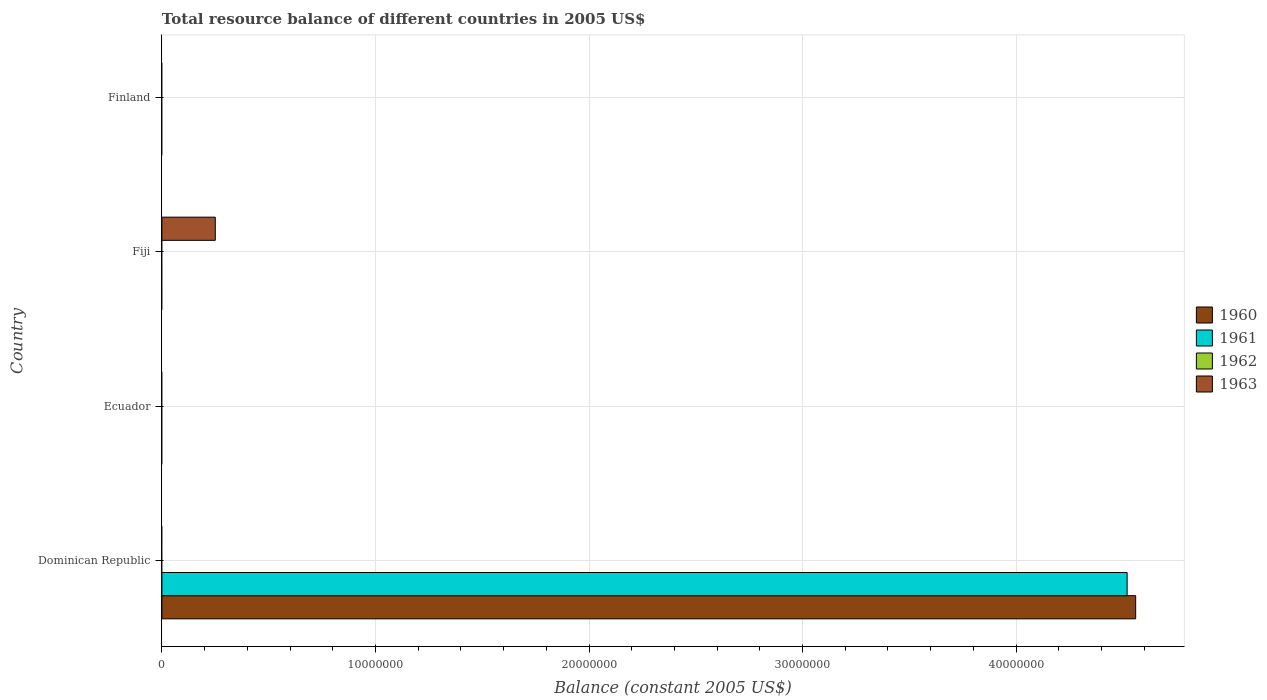How many different coloured bars are there?
Make the answer very short. 3. Are the number of bars on each tick of the Y-axis equal?
Ensure brevity in your answer.  No. How many bars are there on the 2nd tick from the top?
Make the answer very short. 1. What is the label of the 1st group of bars from the top?
Your response must be concise. Finland. Across all countries, what is the maximum total resource balance in 1963?
Offer a terse response. 2.50e+06. Across all countries, what is the minimum total resource balance in 1961?
Offer a very short reply. 0. In which country was the total resource balance in 1961 maximum?
Keep it short and to the point. Dominican Republic. What is the total total resource balance in 1961 in the graph?
Provide a succinct answer. 4.52e+07. What is the difference between the total resource balance in 1961 in Dominican Republic and the total resource balance in 1963 in Ecuador?
Provide a short and direct response. 4.52e+07. What is the average total resource balance in 1961 per country?
Offer a terse response. 1.13e+07. What is the difference between the total resource balance in 1960 and total resource balance in 1961 in Dominican Republic?
Your answer should be compact. 4.00e+05. What is the difference between the highest and the lowest total resource balance in 1960?
Provide a short and direct response. 4.56e+07. Are all the bars in the graph horizontal?
Give a very brief answer. Yes. What is the difference between two consecutive major ticks on the X-axis?
Give a very brief answer. 1.00e+07. Are the values on the major ticks of X-axis written in scientific E-notation?
Your answer should be very brief. No. Does the graph contain grids?
Your answer should be very brief. Yes. Where does the legend appear in the graph?
Keep it short and to the point. Center right. How many legend labels are there?
Keep it short and to the point. 4. What is the title of the graph?
Your answer should be very brief. Total resource balance of different countries in 2005 US$. What is the label or title of the X-axis?
Offer a very short reply. Balance (constant 2005 US$). What is the label or title of the Y-axis?
Provide a succinct answer. Country. What is the Balance (constant 2005 US$) in 1960 in Dominican Republic?
Provide a short and direct response. 4.56e+07. What is the Balance (constant 2005 US$) of 1961 in Dominican Republic?
Your answer should be compact. 4.52e+07. What is the Balance (constant 2005 US$) in 1962 in Dominican Republic?
Provide a short and direct response. 0. What is the Balance (constant 2005 US$) of 1960 in Ecuador?
Offer a very short reply. 0. What is the Balance (constant 2005 US$) of 1963 in Ecuador?
Offer a terse response. 0. What is the Balance (constant 2005 US$) in 1960 in Fiji?
Your answer should be very brief. 0. What is the Balance (constant 2005 US$) of 1961 in Fiji?
Ensure brevity in your answer.  0. What is the Balance (constant 2005 US$) in 1963 in Fiji?
Give a very brief answer. 2.50e+06. Across all countries, what is the maximum Balance (constant 2005 US$) in 1960?
Offer a terse response. 4.56e+07. Across all countries, what is the maximum Balance (constant 2005 US$) of 1961?
Make the answer very short. 4.52e+07. Across all countries, what is the maximum Balance (constant 2005 US$) of 1963?
Your answer should be compact. 2.50e+06. Across all countries, what is the minimum Balance (constant 2005 US$) in 1960?
Make the answer very short. 0. Across all countries, what is the minimum Balance (constant 2005 US$) in 1961?
Offer a very short reply. 0. Across all countries, what is the minimum Balance (constant 2005 US$) in 1963?
Your answer should be compact. 0. What is the total Balance (constant 2005 US$) in 1960 in the graph?
Your answer should be compact. 4.56e+07. What is the total Balance (constant 2005 US$) in 1961 in the graph?
Offer a terse response. 4.52e+07. What is the total Balance (constant 2005 US$) in 1963 in the graph?
Your answer should be very brief. 2.50e+06. What is the difference between the Balance (constant 2005 US$) in 1960 in Dominican Republic and the Balance (constant 2005 US$) in 1963 in Fiji?
Your response must be concise. 4.31e+07. What is the difference between the Balance (constant 2005 US$) in 1961 in Dominican Republic and the Balance (constant 2005 US$) in 1963 in Fiji?
Offer a terse response. 4.27e+07. What is the average Balance (constant 2005 US$) of 1960 per country?
Keep it short and to the point. 1.14e+07. What is the average Balance (constant 2005 US$) in 1961 per country?
Keep it short and to the point. 1.13e+07. What is the average Balance (constant 2005 US$) in 1962 per country?
Make the answer very short. 0. What is the average Balance (constant 2005 US$) in 1963 per country?
Ensure brevity in your answer.  6.25e+05. What is the difference between the highest and the lowest Balance (constant 2005 US$) of 1960?
Make the answer very short. 4.56e+07. What is the difference between the highest and the lowest Balance (constant 2005 US$) of 1961?
Keep it short and to the point. 4.52e+07. What is the difference between the highest and the lowest Balance (constant 2005 US$) in 1963?
Keep it short and to the point. 2.50e+06. 